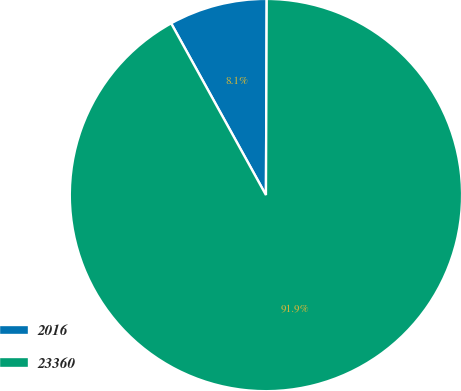Convert chart to OTSL. <chart><loc_0><loc_0><loc_500><loc_500><pie_chart><fcel>2016<fcel>23360<nl><fcel>8.09%<fcel>91.91%<nl></chart> 